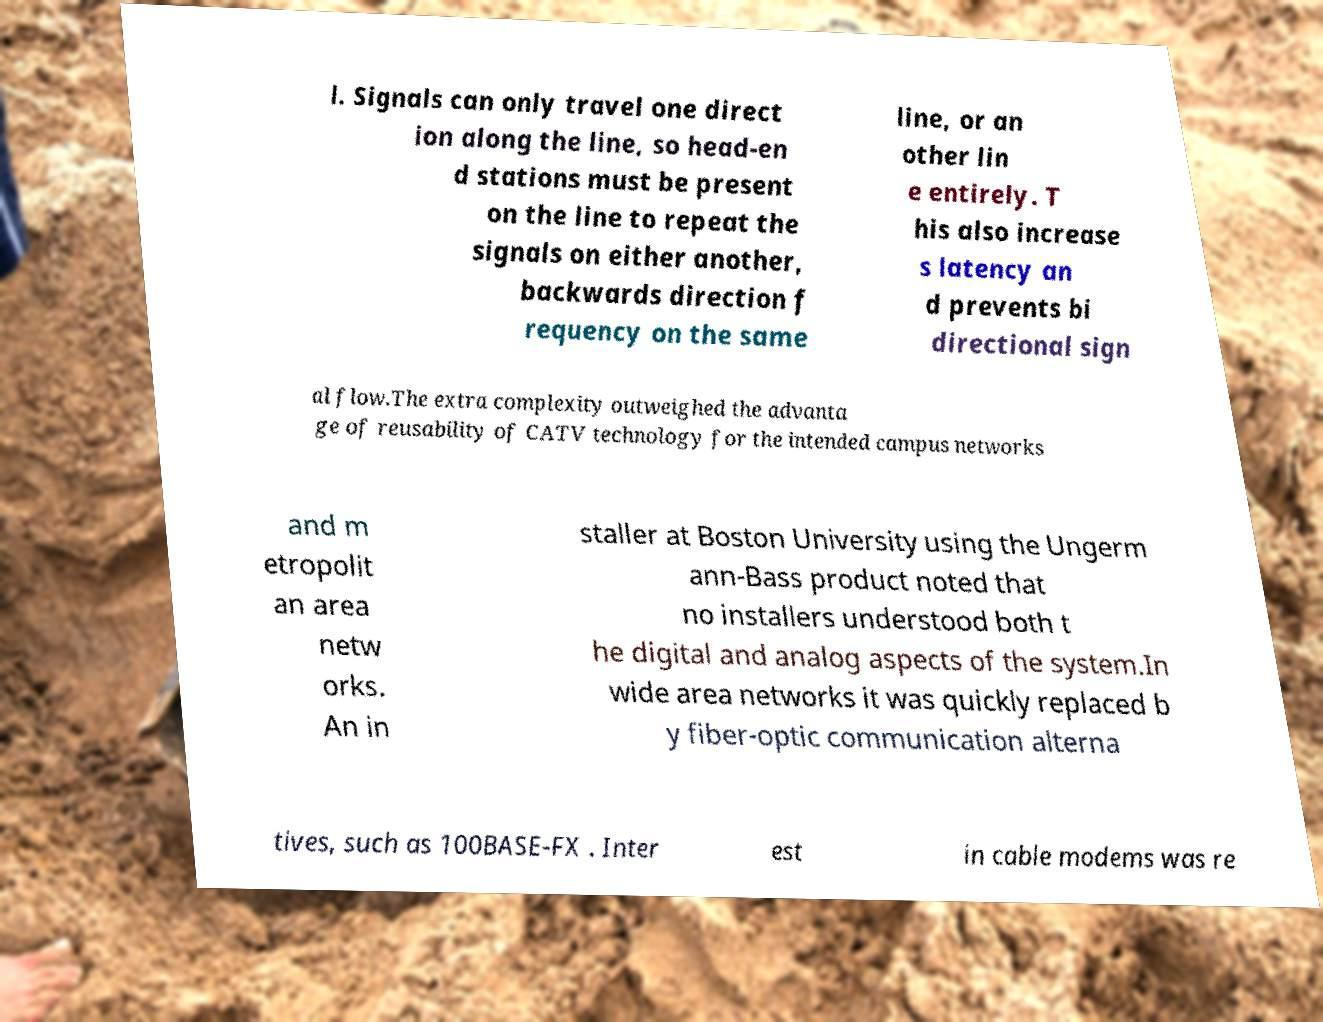Please read and relay the text visible in this image. What does it say? l. Signals can only travel one direct ion along the line, so head-en d stations must be present on the line to repeat the signals on either another, backwards direction f requency on the same line, or an other lin e entirely. T his also increase s latency an d prevents bi directional sign al flow.The extra complexity outweighed the advanta ge of reusability of CATV technology for the intended campus networks and m etropolit an area netw orks. An in staller at Boston University using the Ungerm ann-Bass product noted that no installers understood both t he digital and analog aspects of the system.In wide area networks it was quickly replaced b y fiber-optic communication alterna tives, such as 100BASE-FX . Inter est in cable modems was re 